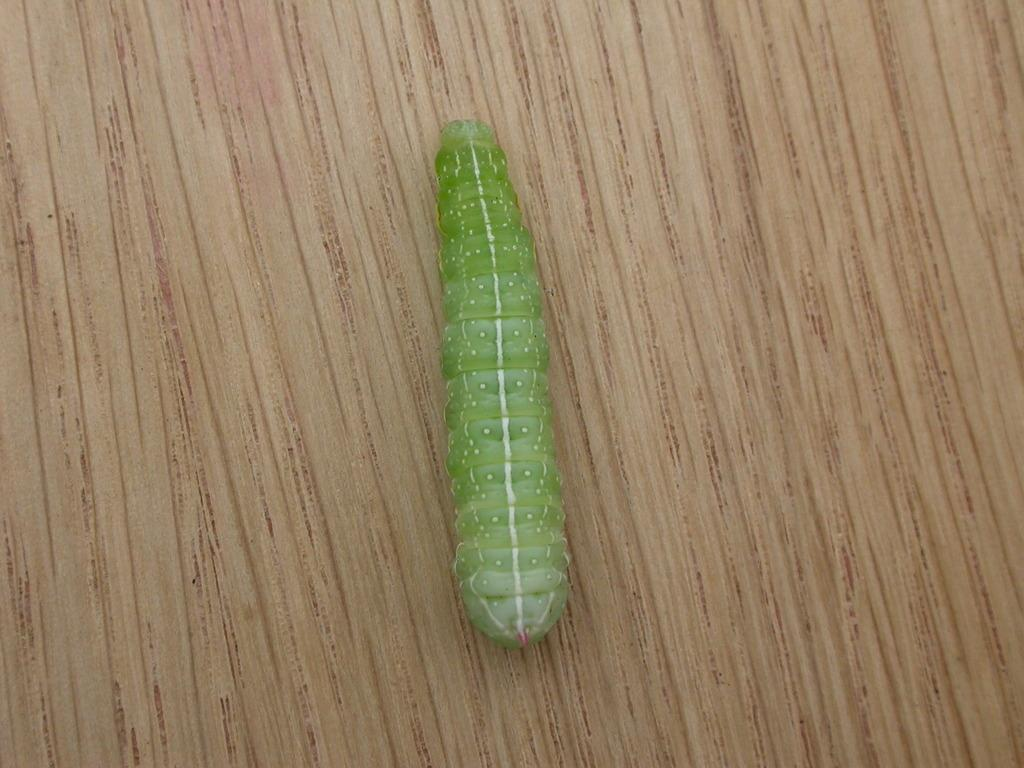What is the main subject of the image? The main subject of the image is a caterpillar. Where is the caterpillar located in the image? The caterpillar is on wood. Can you see the caterpillar folding its legs in the image? There is no indication in the image that the caterpillar is folding its legs. 